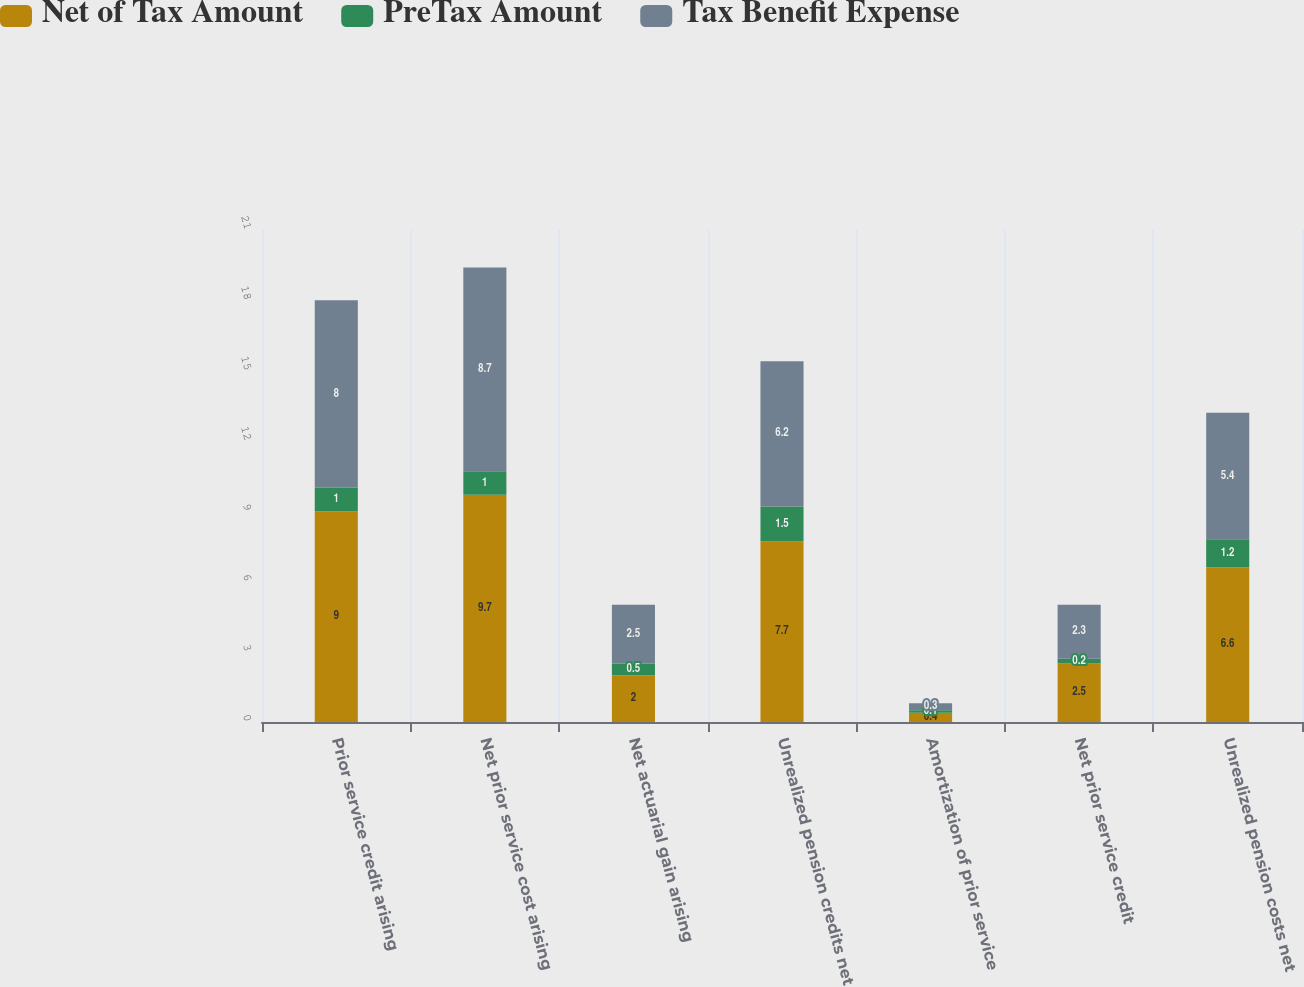<chart> <loc_0><loc_0><loc_500><loc_500><stacked_bar_chart><ecel><fcel>Prior service credit arising<fcel>Net prior service cost arising<fcel>Net actuarial gain arising<fcel>Unrealized pension credits net<fcel>Amortization of prior service<fcel>Net prior service credit<fcel>Unrealized pension costs net<nl><fcel>Net of Tax Amount<fcel>9<fcel>9.7<fcel>2<fcel>7.7<fcel>0.4<fcel>2.5<fcel>6.6<nl><fcel>PreTax Amount<fcel>1<fcel>1<fcel>0.5<fcel>1.5<fcel>0.1<fcel>0.2<fcel>1.2<nl><fcel>Tax Benefit Expense<fcel>8<fcel>8.7<fcel>2.5<fcel>6.2<fcel>0.3<fcel>2.3<fcel>5.4<nl></chart> 